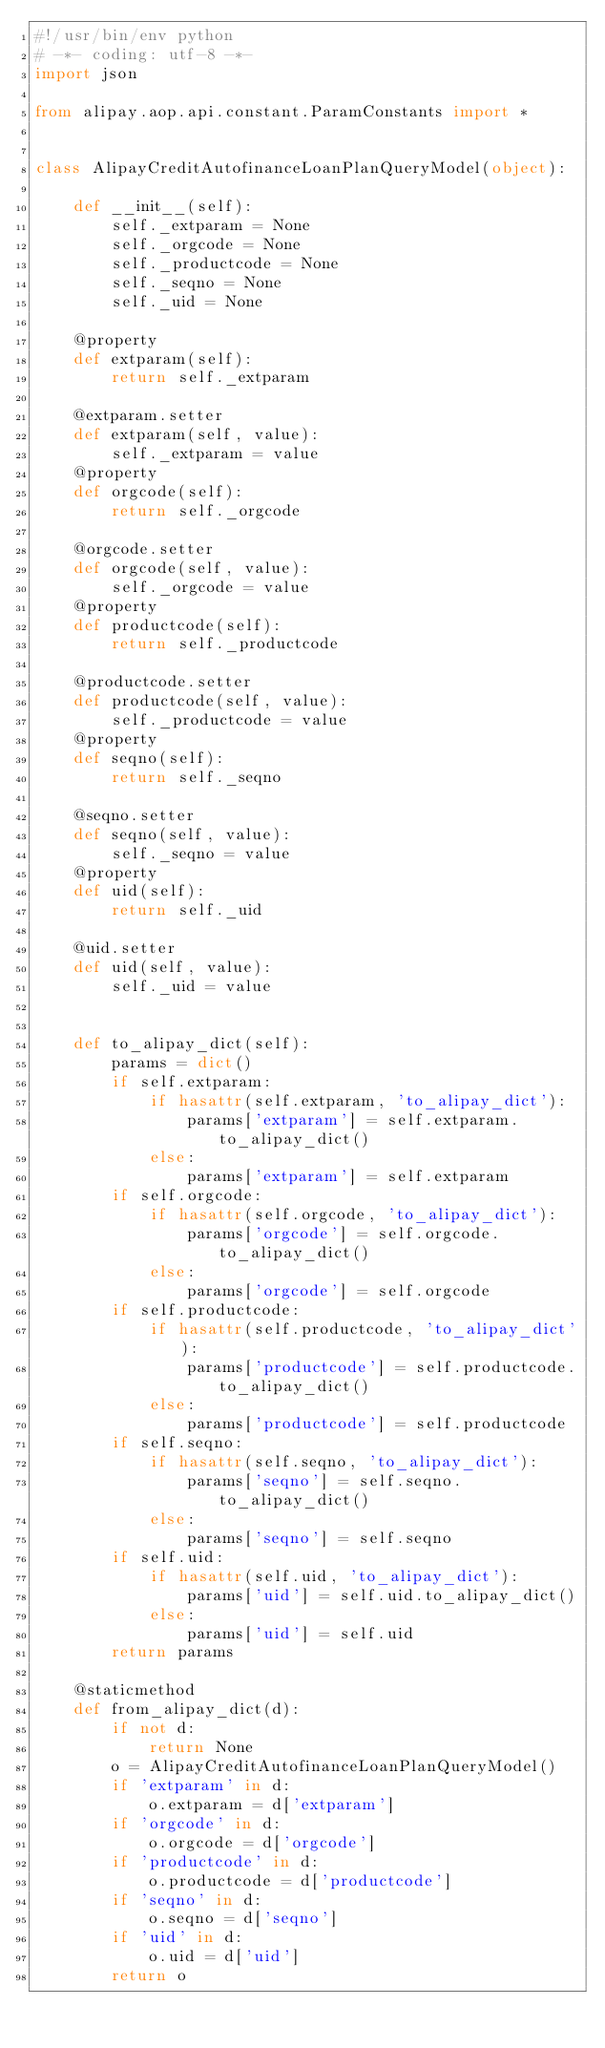Convert code to text. <code><loc_0><loc_0><loc_500><loc_500><_Python_>#!/usr/bin/env python
# -*- coding: utf-8 -*-
import json

from alipay.aop.api.constant.ParamConstants import *


class AlipayCreditAutofinanceLoanPlanQueryModel(object):

    def __init__(self):
        self._extparam = None
        self._orgcode = None
        self._productcode = None
        self._seqno = None
        self._uid = None

    @property
    def extparam(self):
        return self._extparam

    @extparam.setter
    def extparam(self, value):
        self._extparam = value
    @property
    def orgcode(self):
        return self._orgcode

    @orgcode.setter
    def orgcode(self, value):
        self._orgcode = value
    @property
    def productcode(self):
        return self._productcode

    @productcode.setter
    def productcode(self, value):
        self._productcode = value
    @property
    def seqno(self):
        return self._seqno

    @seqno.setter
    def seqno(self, value):
        self._seqno = value
    @property
    def uid(self):
        return self._uid

    @uid.setter
    def uid(self, value):
        self._uid = value


    def to_alipay_dict(self):
        params = dict()
        if self.extparam:
            if hasattr(self.extparam, 'to_alipay_dict'):
                params['extparam'] = self.extparam.to_alipay_dict()
            else:
                params['extparam'] = self.extparam
        if self.orgcode:
            if hasattr(self.orgcode, 'to_alipay_dict'):
                params['orgcode'] = self.orgcode.to_alipay_dict()
            else:
                params['orgcode'] = self.orgcode
        if self.productcode:
            if hasattr(self.productcode, 'to_alipay_dict'):
                params['productcode'] = self.productcode.to_alipay_dict()
            else:
                params['productcode'] = self.productcode
        if self.seqno:
            if hasattr(self.seqno, 'to_alipay_dict'):
                params['seqno'] = self.seqno.to_alipay_dict()
            else:
                params['seqno'] = self.seqno
        if self.uid:
            if hasattr(self.uid, 'to_alipay_dict'):
                params['uid'] = self.uid.to_alipay_dict()
            else:
                params['uid'] = self.uid
        return params

    @staticmethod
    def from_alipay_dict(d):
        if not d:
            return None
        o = AlipayCreditAutofinanceLoanPlanQueryModel()
        if 'extparam' in d:
            o.extparam = d['extparam']
        if 'orgcode' in d:
            o.orgcode = d['orgcode']
        if 'productcode' in d:
            o.productcode = d['productcode']
        if 'seqno' in d:
            o.seqno = d['seqno']
        if 'uid' in d:
            o.uid = d['uid']
        return o


</code> 